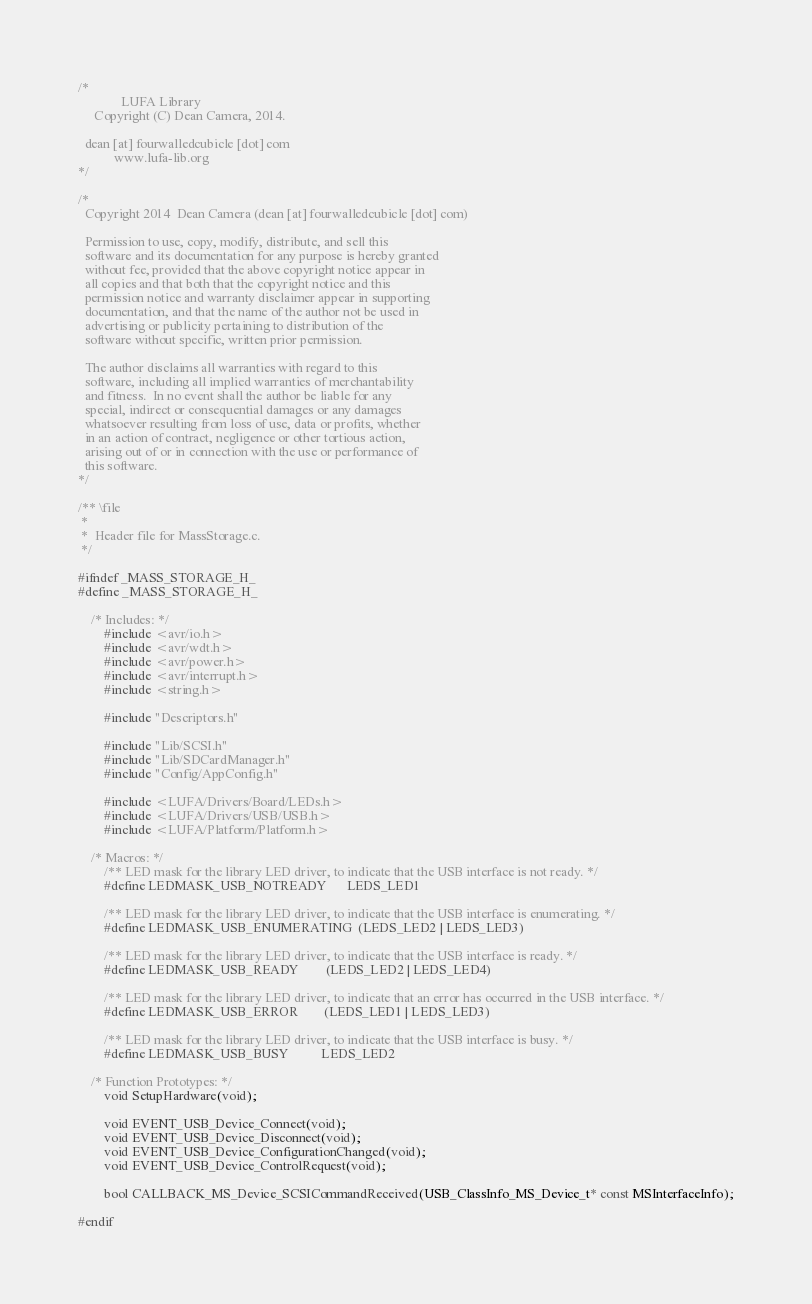Convert code to text. <code><loc_0><loc_0><loc_500><loc_500><_C_>/*
             LUFA Library
     Copyright (C) Dean Camera, 2014.

  dean [at] fourwalledcubicle [dot] com
           www.lufa-lib.org
*/

/*
  Copyright 2014  Dean Camera (dean [at] fourwalledcubicle [dot] com)

  Permission to use, copy, modify, distribute, and sell this
  software and its documentation for any purpose is hereby granted
  without fee, provided that the above copyright notice appear in
  all copies and that both that the copyright notice and this
  permission notice and warranty disclaimer appear in supporting
  documentation, and that the name of the author not be used in
  advertising or publicity pertaining to distribution of the
  software without specific, written prior permission.

  The author disclaims all warranties with regard to this
  software, including all implied warranties of merchantability
  and fitness.  In no event shall the author be liable for any
  special, indirect or consequential damages or any damages
  whatsoever resulting from loss of use, data or profits, whether
  in an action of contract, negligence or other tortious action,
  arising out of or in connection with the use or performance of
  this software.
*/

/** \file
 *
 *  Header file for MassStorage.c.
 */

#ifndef _MASS_STORAGE_H_
#define _MASS_STORAGE_H_

	/* Includes: */
		#include <avr/io.h>
		#include <avr/wdt.h>
		#include <avr/power.h>
		#include <avr/interrupt.h>
		#include <string.h>

		#include "Descriptors.h"

		#include "Lib/SCSI.h"
		#include "Lib/SDCardManager.h"
		#include "Config/AppConfig.h"

		#include <LUFA/Drivers/Board/LEDs.h>
		#include <LUFA/Drivers/USB/USB.h>
		#include <LUFA/Platform/Platform.h>

	/* Macros: */
		/** LED mask for the library LED driver, to indicate that the USB interface is not ready. */
		#define LEDMASK_USB_NOTREADY      LEDS_LED1

		/** LED mask for the library LED driver, to indicate that the USB interface is enumerating. */
		#define LEDMASK_USB_ENUMERATING  (LEDS_LED2 | LEDS_LED3)

		/** LED mask for the library LED driver, to indicate that the USB interface is ready. */
		#define LEDMASK_USB_READY        (LEDS_LED2 | LEDS_LED4)

		/** LED mask for the library LED driver, to indicate that an error has occurred in the USB interface. */
		#define LEDMASK_USB_ERROR        (LEDS_LED1 | LEDS_LED3)

		/** LED mask for the library LED driver, to indicate that the USB interface is busy. */
		#define LEDMASK_USB_BUSY          LEDS_LED2

	/* Function Prototypes: */
		void SetupHardware(void);

		void EVENT_USB_Device_Connect(void);
		void EVENT_USB_Device_Disconnect(void);
		void EVENT_USB_Device_ConfigurationChanged(void);
		void EVENT_USB_Device_ControlRequest(void);

		bool CALLBACK_MS_Device_SCSICommandReceived(USB_ClassInfo_MS_Device_t* const MSInterfaceInfo);

#endif

</code> 